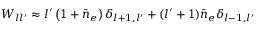Convert formula to latex. <formula><loc_0><loc_0><loc_500><loc_500>\begin{array} { r } { W _ { l l ^ { \prime } } \approx l ^ { \prime } \left ( 1 + \bar { n } _ { e } \right ) \delta _ { l + 1 , l ^ { \prime } } + ( l ^ { \prime } + 1 ) \bar { n } _ { e } \delta _ { l - 1 , l ^ { \prime } } } \end{array}</formula> 